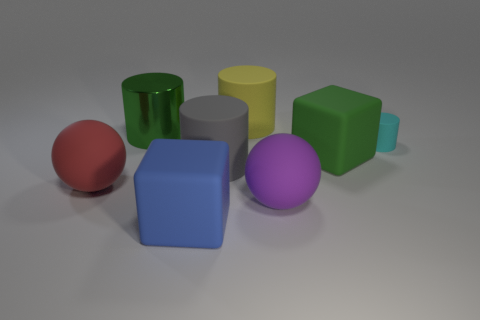Add 1 green rubber cylinders. How many objects exist? 9 Subtract all cubes. How many objects are left? 6 Add 2 blue cubes. How many blue cubes are left? 3 Add 2 shiny cylinders. How many shiny cylinders exist? 3 Subtract 1 red spheres. How many objects are left? 7 Subtract all green things. Subtract all large purple things. How many objects are left? 5 